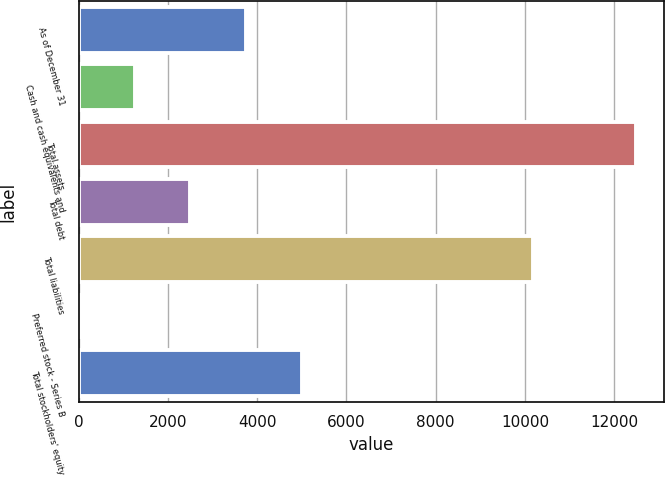Convert chart to OTSL. <chart><loc_0><loc_0><loc_500><loc_500><bar_chart><fcel>As of December 31<fcel>Cash and cash equivalents and<fcel>Total assets<fcel>Total debt<fcel>Total liabilities<fcel>Preferred stock - Series B<fcel>Total stockholders' equity<nl><fcel>3748.48<fcel>1252.28<fcel>12485.2<fcel>2500.38<fcel>10175.7<fcel>4.18<fcel>4996.58<nl></chart> 